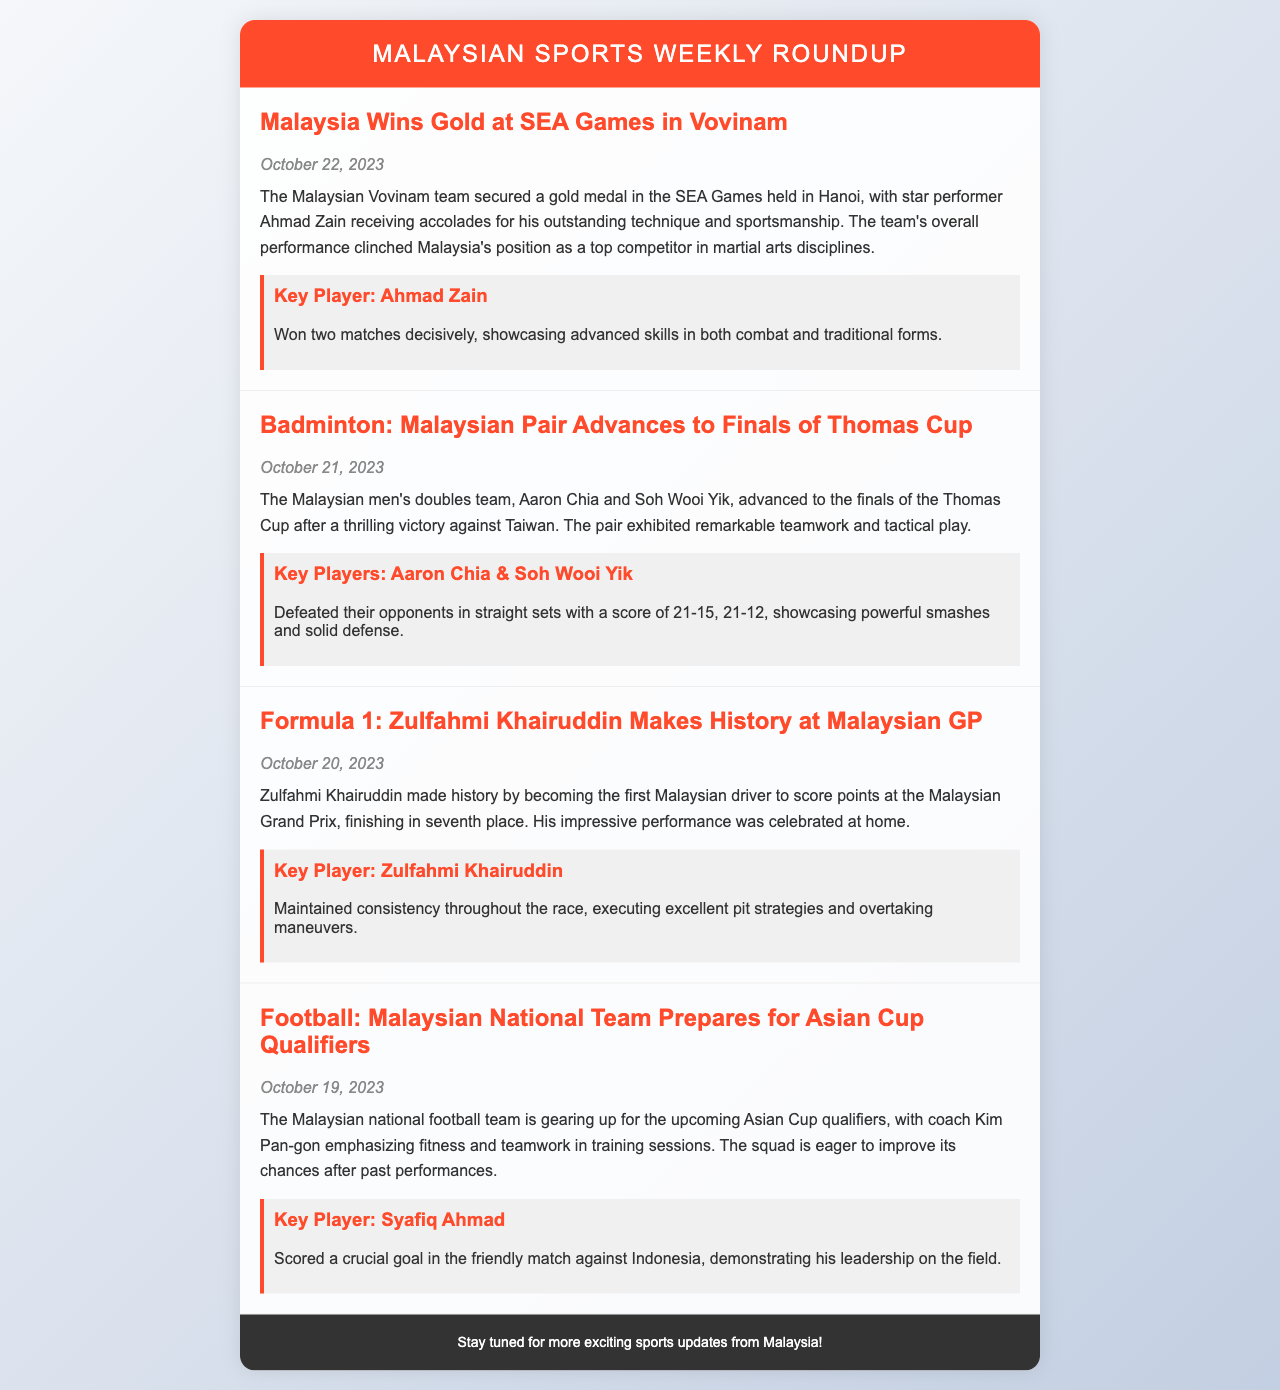What did Malaysia win at the SEA Games? Malaysia secured a gold medal in Vovinam at the SEA Games.
Answer: Gold medal Who is the key player for Malaysia in the Vovinam event? The key player for Malaysia in Vovinam is Ahmad Zain.
Answer: Ahmad Zain What date did the Malaysian men's doubles team advance to the finals of the Thomas Cup? The date the Malaysian men's doubles team advanced to the finals was October 21, 2023.
Answer: October 21, 2023 How did Zulfahmi Khairuddin perform at the Malaysian Grand Prix? Zulfahmi Khairuddin finished in seventh place, scoring points and making history.
Answer: Seventh place Which player scored a crucial goal for Malaysia in a friendly match against Indonesia? The player who scored a crucial goal was Syafiq Ahmad.
Answer: Syafiq Ahmad What did coach Kim Pan-gon emphasize during the training sessions? Coach Kim Pan-gon emphasized fitness and teamwork in training sessions.
Answer: Fitness and teamwork What sport did Malaysia secure a gold medal in? Malaysia secured a gold medal in Vovinam.
Answer: Vovinam When did Zulfahmi Khairuddin make history at the Malaysian GP? Zulfahmi Khairuddin made history at the Malaysian GP on October 20, 2023.
Answer: October 20, 2023 What is the summary of the Malaysian national football team’s preparation? The Malaysian national football team is preparing for Asian Cup qualifiers with focus on fitness and teamwork.
Answer: Preparation for Asian Cup qualifiers 